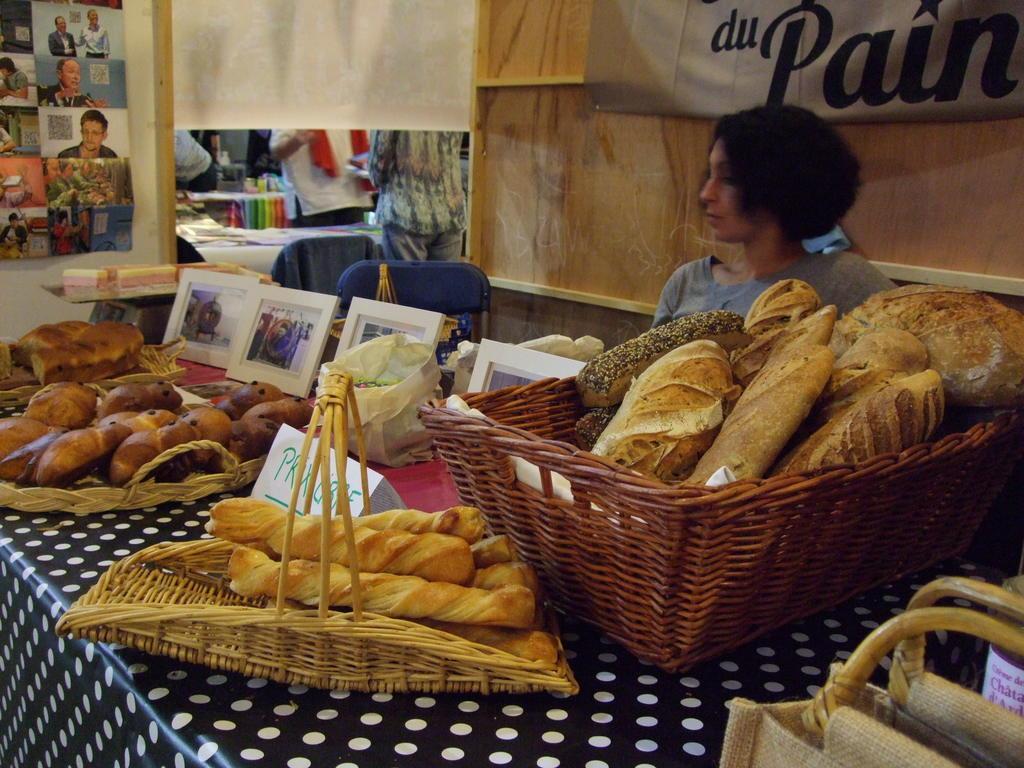Please provide a concise description of this image. On this table there are baskets, pictures, bags and food. Beside this table there is a person. Here we can see banners, chairs and people. Poster is on the wall. 